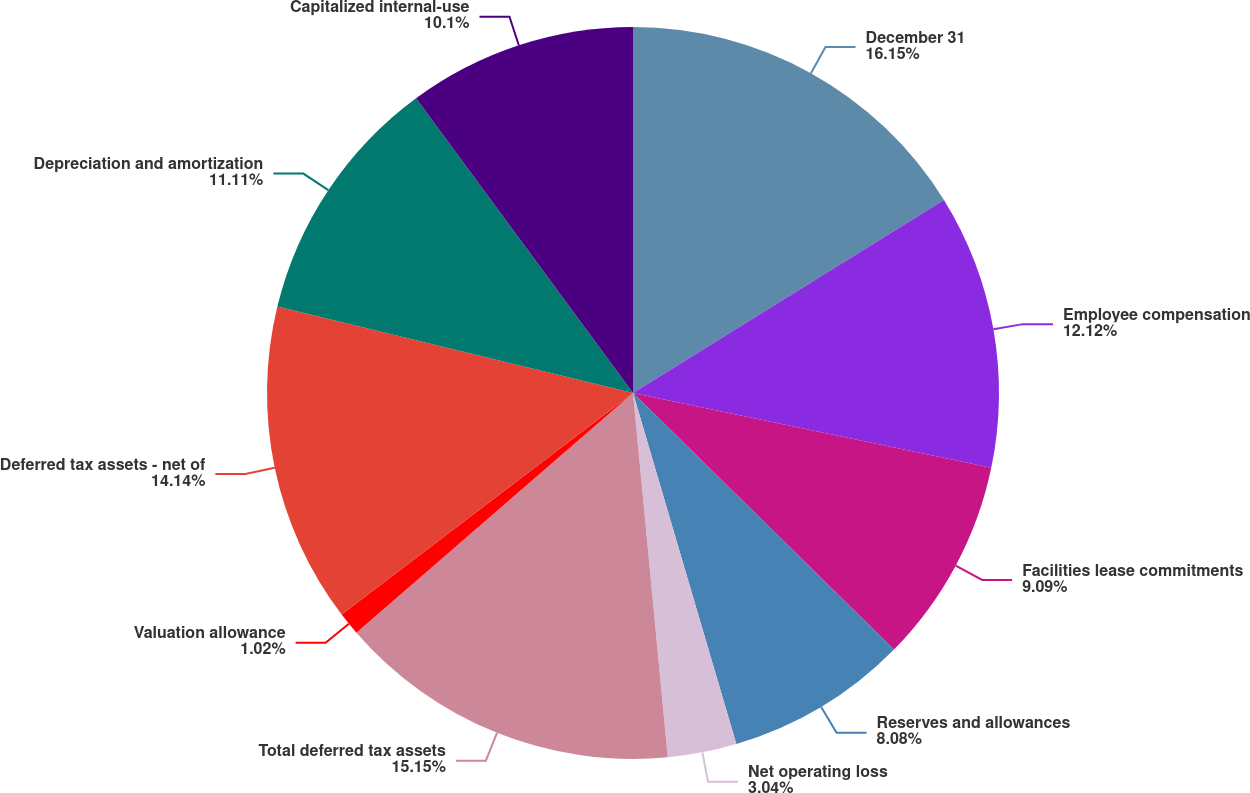Convert chart. <chart><loc_0><loc_0><loc_500><loc_500><pie_chart><fcel>December 31<fcel>Employee compensation<fcel>Facilities lease commitments<fcel>Reserves and allowances<fcel>Net operating loss<fcel>Total deferred tax assets<fcel>Valuation allowance<fcel>Deferred tax assets - net of<fcel>Depreciation and amortization<fcel>Capitalized internal-use<nl><fcel>16.16%<fcel>12.12%<fcel>9.09%<fcel>8.08%<fcel>3.04%<fcel>15.15%<fcel>1.02%<fcel>14.14%<fcel>11.11%<fcel>10.1%<nl></chart> 